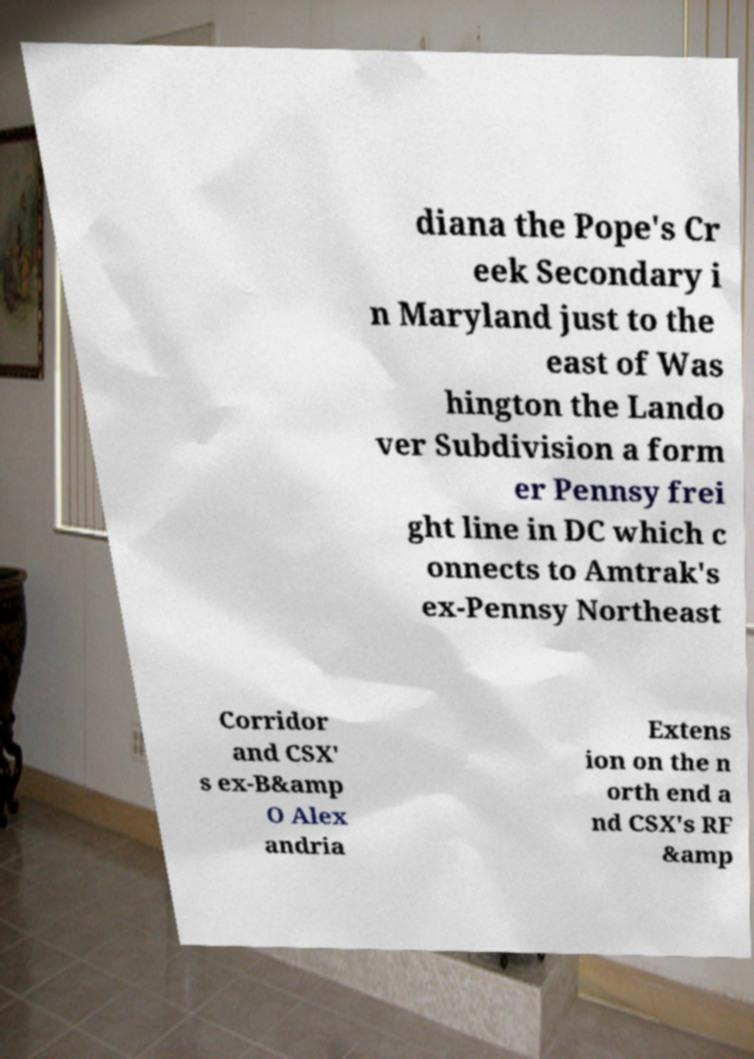Please identify and transcribe the text found in this image. diana the Pope's Cr eek Secondary i n Maryland just to the east of Was hington the Lando ver Subdivision a form er Pennsy frei ght line in DC which c onnects to Amtrak's ex-Pennsy Northeast Corridor and CSX' s ex-B&amp O Alex andria Extens ion on the n orth end a nd CSX's RF &amp 